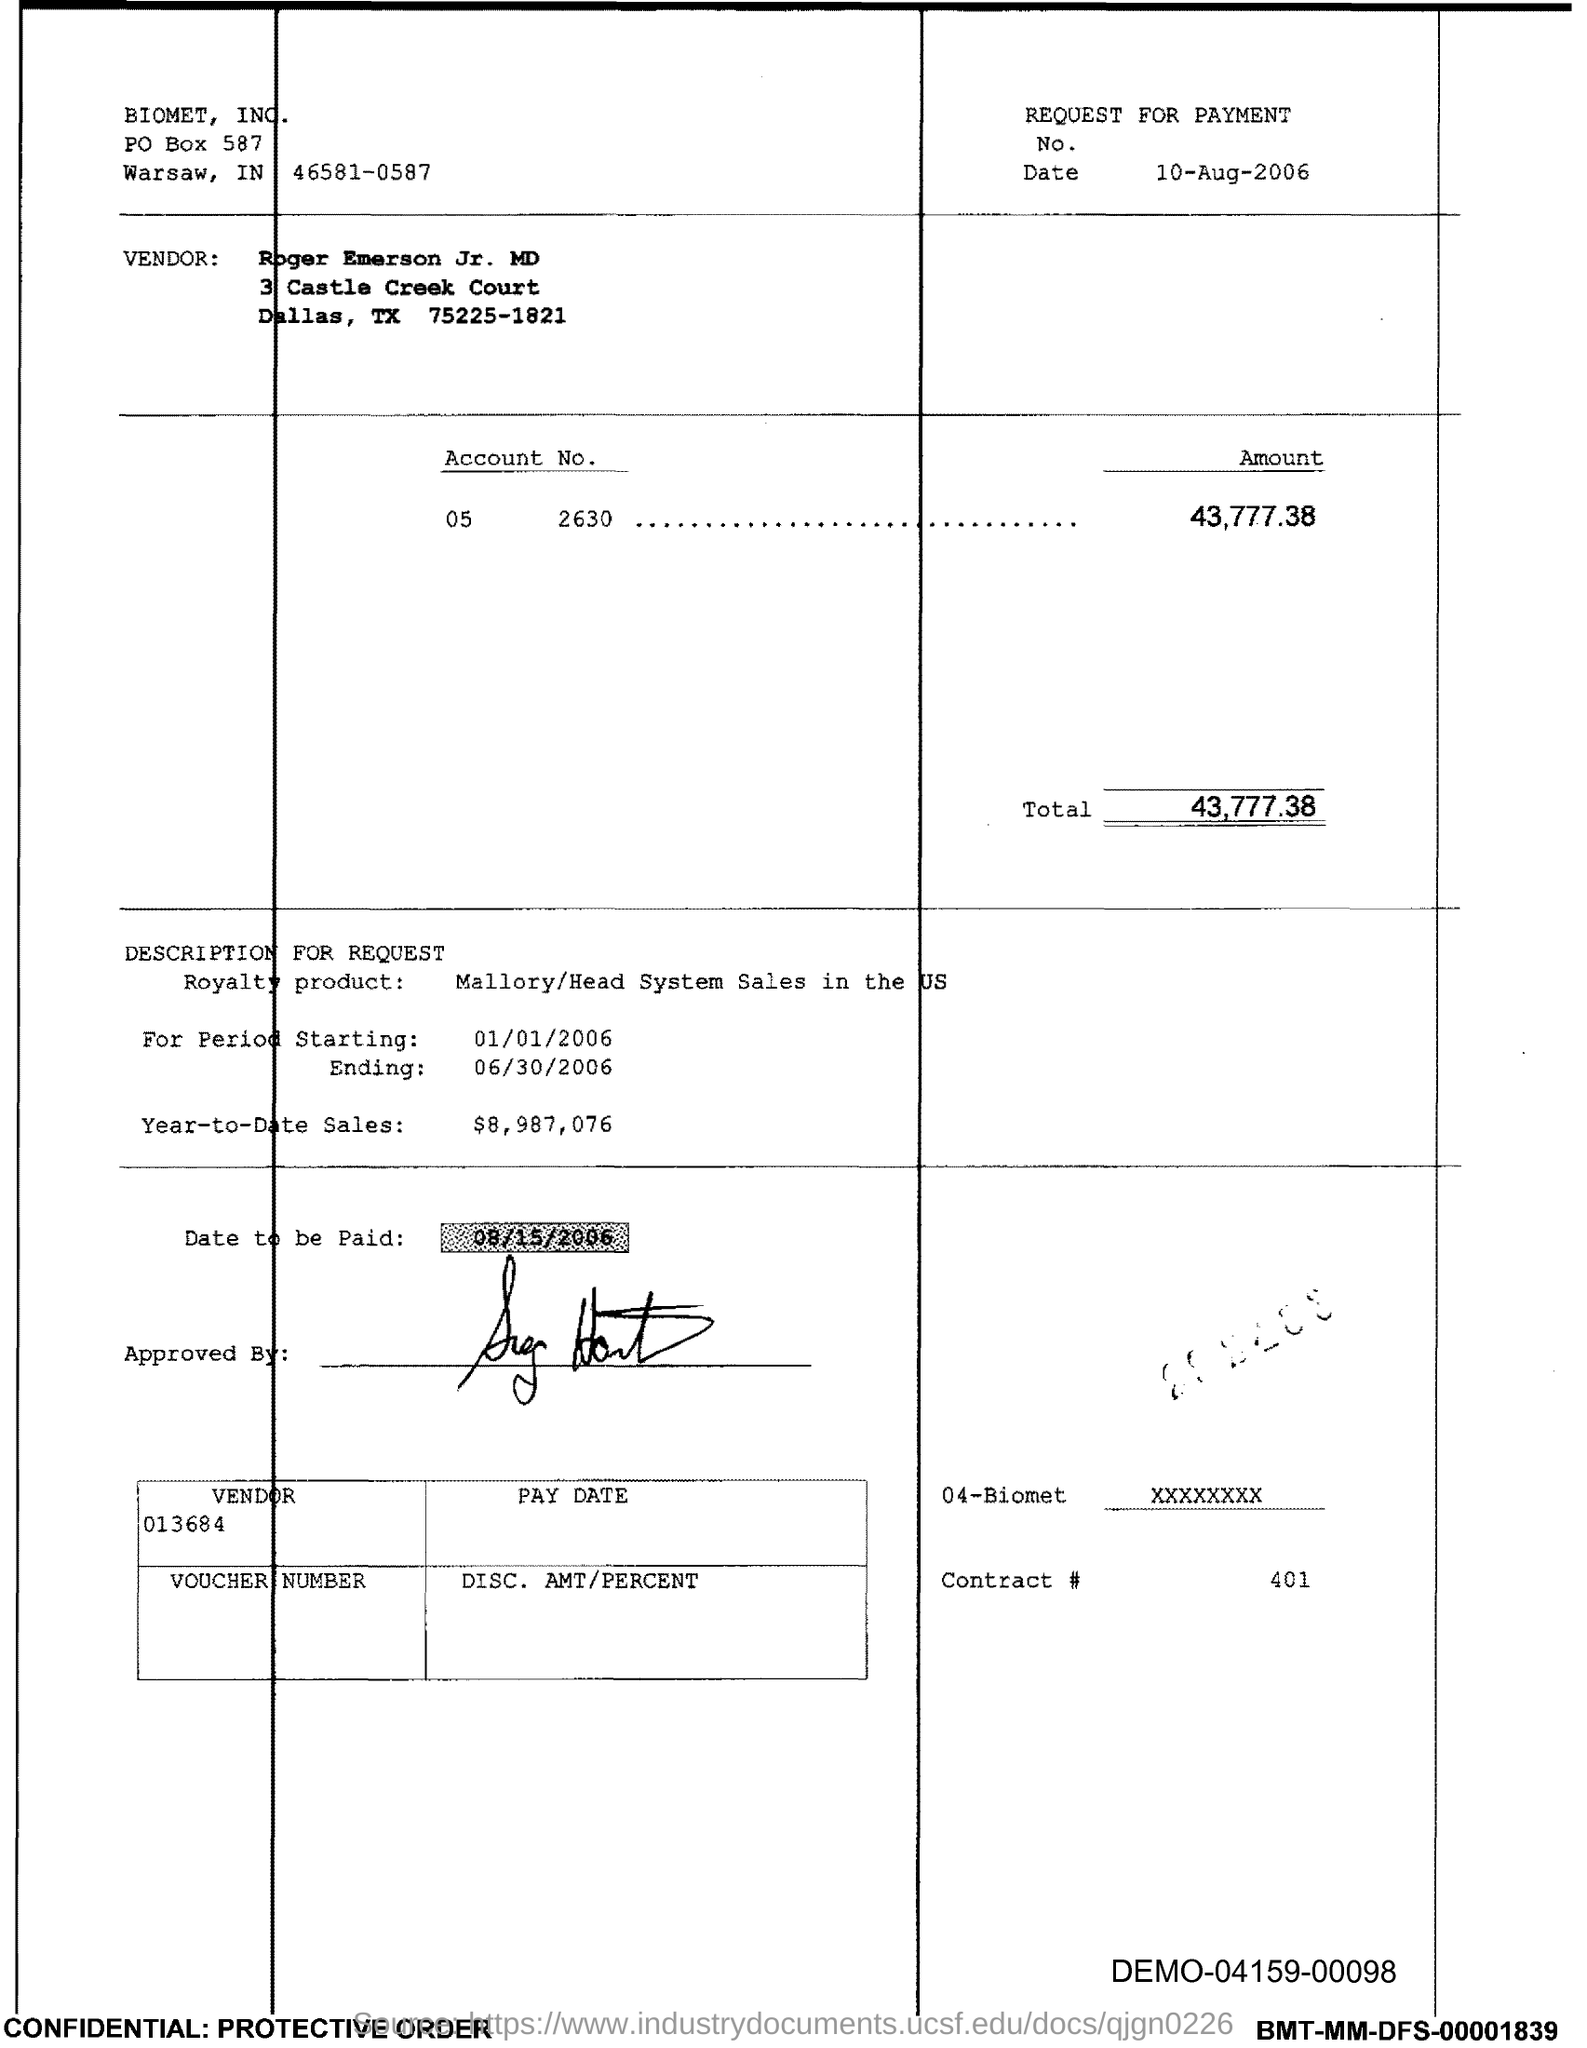Mention a couple of crucial points in this snapshot. The contract number mentioned in the voucher is 401. The end date of the royalty period is June 30, 2006. The start date of the royalty period is January 1st, 2006. The total amount mentioned in the voucher is 43,777.38. The account number given in the voucher is 05 2630. 